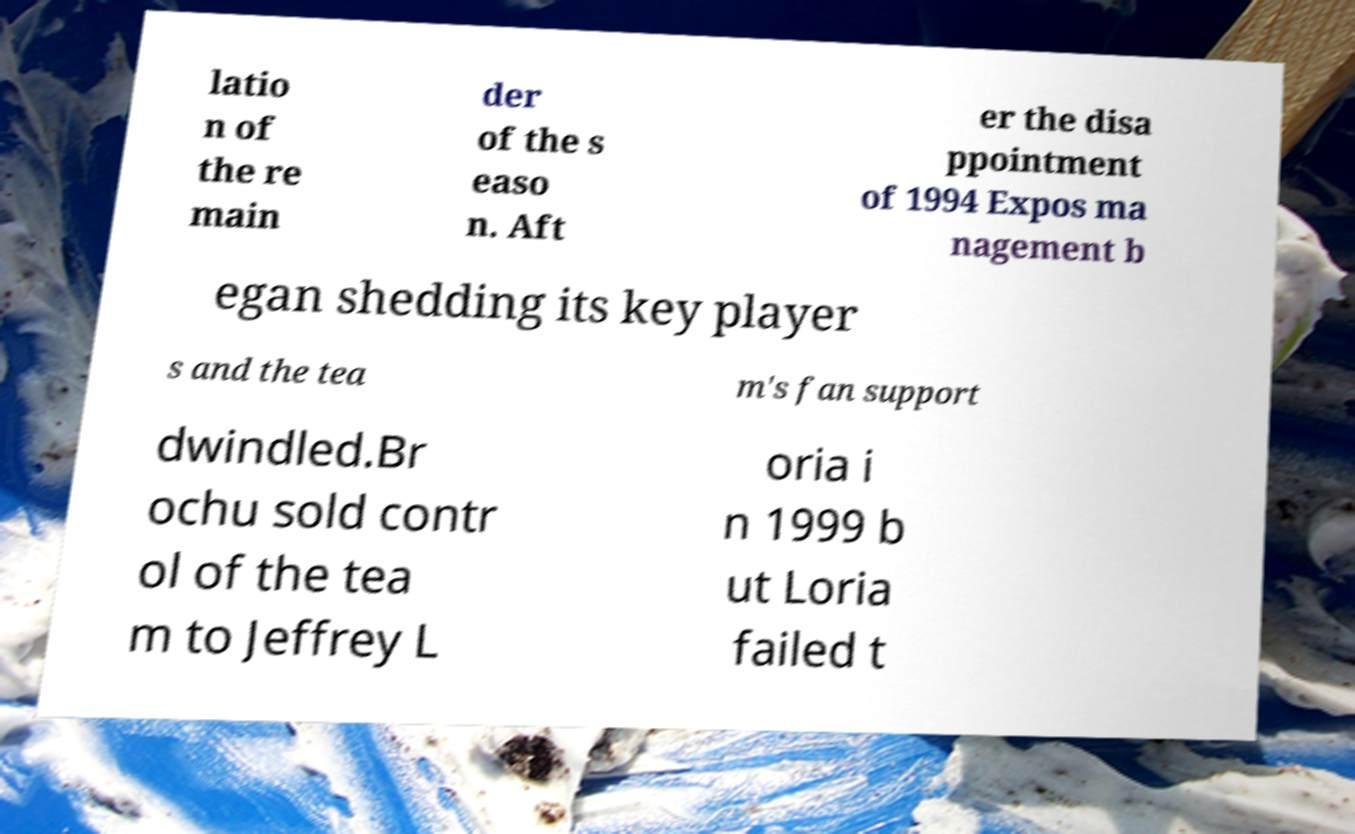Can you accurately transcribe the text from the provided image for me? latio n of the re main der of the s easo n. Aft er the disa ppointment of 1994 Expos ma nagement b egan shedding its key player s and the tea m's fan support dwindled.Br ochu sold contr ol of the tea m to Jeffrey L oria i n 1999 b ut Loria failed t 